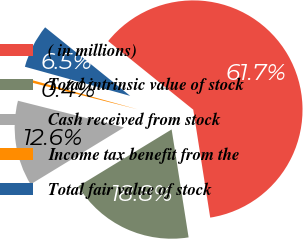<chart> <loc_0><loc_0><loc_500><loc_500><pie_chart><fcel>( in millions)<fcel>Total intrinsic value of stock<fcel>Cash received from stock<fcel>Income tax benefit from the<fcel>Total fair value of stock<nl><fcel>61.72%<fcel>18.77%<fcel>12.64%<fcel>0.37%<fcel>6.5%<nl></chart> 